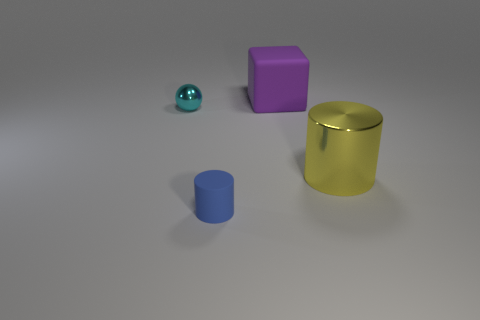What is the color of the thing that is both behind the big metallic cylinder and on the right side of the sphere?
Keep it short and to the point. Purple. How many large objects are either yellow things or blue metallic cylinders?
Keep it short and to the point. 1. There is another object that is the same shape as the blue thing; what size is it?
Give a very brief answer. Large. What is the shape of the purple matte thing?
Offer a terse response. Cube. Is the large yellow object made of the same material as the cylinder that is to the left of the purple rubber cube?
Give a very brief answer. No. How many metal things are brown things or big cubes?
Keep it short and to the point. 0. There is a purple matte cube behind the small metallic object; what size is it?
Offer a very short reply. Large. What is the size of the purple block that is the same material as the small blue thing?
Offer a terse response. Large. How many other matte objects have the same color as the big matte object?
Make the answer very short. 0. Is there a gray rubber cube?
Give a very brief answer. No. 